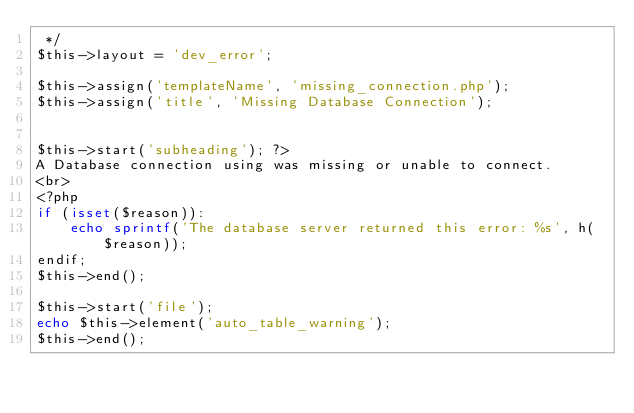Convert code to text. <code><loc_0><loc_0><loc_500><loc_500><_PHP_> */
$this->layout = 'dev_error';

$this->assign('templateName', 'missing_connection.php');
$this->assign('title', 'Missing Database Connection');


$this->start('subheading'); ?>
A Database connection using was missing or unable to connect.
<br>
<?php
if (isset($reason)):
    echo sprintf('The database server returned this error: %s', h($reason));
endif;
$this->end();

$this->start('file');
echo $this->element('auto_table_warning');
$this->end();
</code> 